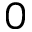<formula> <loc_0><loc_0><loc_500><loc_500>0</formula> 